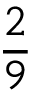Convert formula to latex. <formula><loc_0><loc_0><loc_500><loc_500>\frac { 2 } { 9 }</formula> 